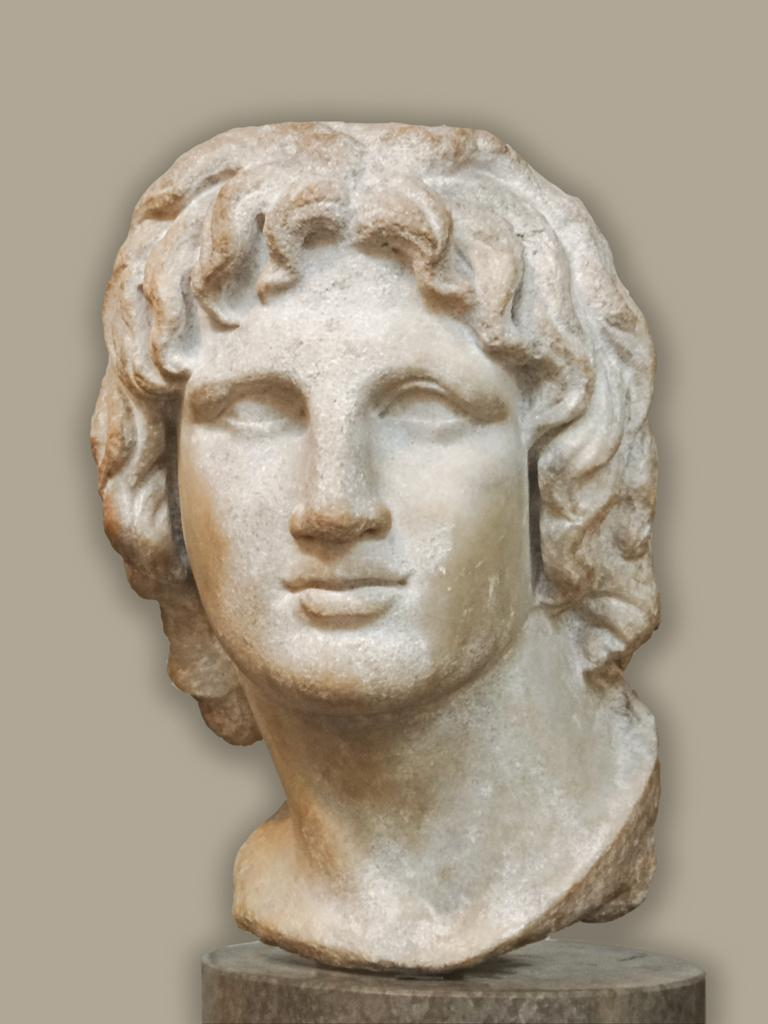What is the main subject of the image? There is a sculpture in the image. What color is the sculpture? The sculpture is white in color. What can be seen in the background of the image? The background of the image is white. How many brothers are depicted in the sculpture in the image? There are no brothers depicted in the sculpture in the image, as the sculpture is not a representation of people. 